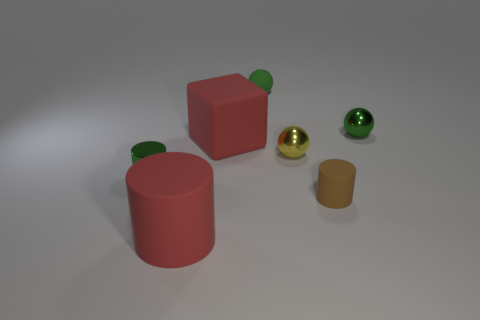Add 1 green matte cylinders. How many objects exist? 8 Subtract all balls. How many objects are left? 4 Add 5 metal cylinders. How many metal cylinders exist? 6 Subtract 1 red cylinders. How many objects are left? 6 Subtract all small green metallic cylinders. Subtract all tiny green shiny cylinders. How many objects are left? 5 Add 6 yellow metallic balls. How many yellow metallic balls are left? 7 